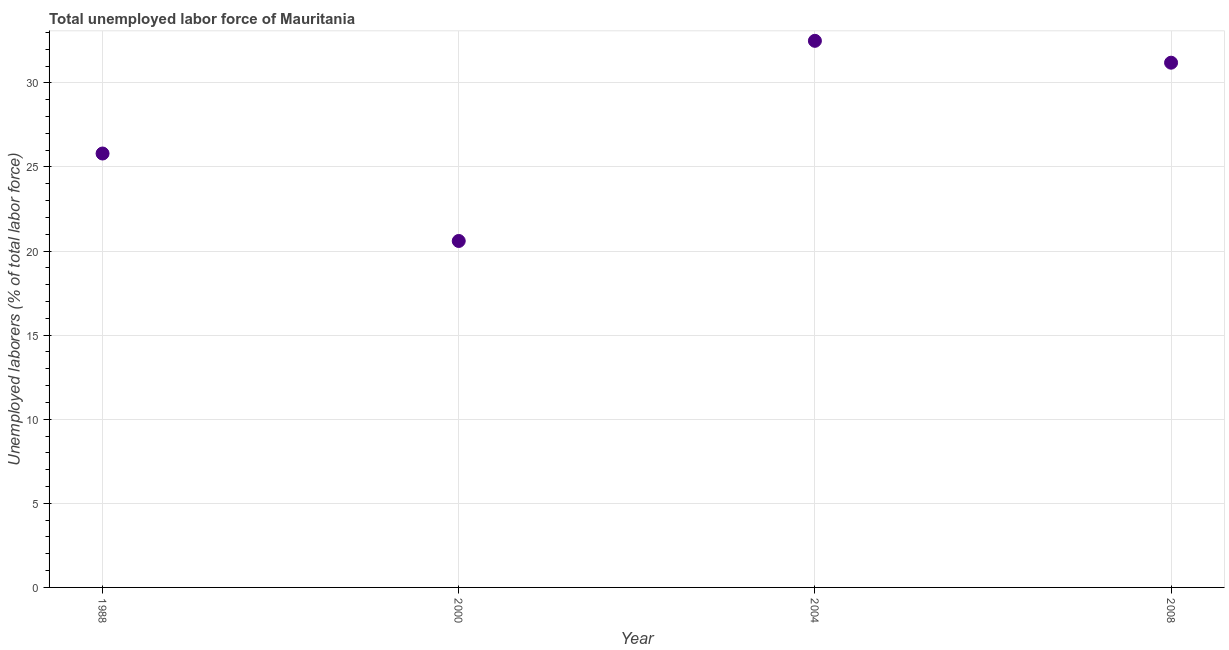What is the total unemployed labour force in 2000?
Make the answer very short. 20.6. Across all years, what is the maximum total unemployed labour force?
Your answer should be very brief. 32.5. Across all years, what is the minimum total unemployed labour force?
Your response must be concise. 20.6. In which year was the total unemployed labour force maximum?
Offer a very short reply. 2004. In which year was the total unemployed labour force minimum?
Offer a very short reply. 2000. What is the sum of the total unemployed labour force?
Your response must be concise. 110.1. What is the difference between the total unemployed labour force in 2000 and 2004?
Your answer should be compact. -11.9. What is the average total unemployed labour force per year?
Offer a very short reply. 27.53. What is the median total unemployed labour force?
Provide a short and direct response. 28.5. Do a majority of the years between 2004 and 2000 (inclusive) have total unemployed labour force greater than 13 %?
Keep it short and to the point. No. What is the ratio of the total unemployed labour force in 1988 to that in 2004?
Provide a short and direct response. 0.79. Is the total unemployed labour force in 2000 less than that in 2004?
Offer a terse response. Yes. Is the difference between the total unemployed labour force in 2004 and 2008 greater than the difference between any two years?
Provide a short and direct response. No. What is the difference between the highest and the second highest total unemployed labour force?
Make the answer very short. 1.3. What is the difference between the highest and the lowest total unemployed labour force?
Offer a very short reply. 11.9. Does the total unemployed labour force monotonically increase over the years?
Keep it short and to the point. No. How many years are there in the graph?
Keep it short and to the point. 4. Are the values on the major ticks of Y-axis written in scientific E-notation?
Give a very brief answer. No. What is the title of the graph?
Offer a terse response. Total unemployed labor force of Mauritania. What is the label or title of the X-axis?
Provide a short and direct response. Year. What is the label or title of the Y-axis?
Make the answer very short. Unemployed laborers (% of total labor force). What is the Unemployed laborers (% of total labor force) in 1988?
Offer a terse response. 25.8. What is the Unemployed laborers (% of total labor force) in 2000?
Your response must be concise. 20.6. What is the Unemployed laborers (% of total labor force) in 2004?
Offer a terse response. 32.5. What is the Unemployed laborers (% of total labor force) in 2008?
Provide a succinct answer. 31.2. What is the difference between the Unemployed laborers (% of total labor force) in 1988 and 2000?
Provide a short and direct response. 5.2. What is the difference between the Unemployed laborers (% of total labor force) in 1988 and 2004?
Keep it short and to the point. -6.7. What is the difference between the Unemployed laborers (% of total labor force) in 1988 and 2008?
Keep it short and to the point. -5.4. What is the difference between the Unemployed laborers (% of total labor force) in 2004 and 2008?
Your answer should be very brief. 1.3. What is the ratio of the Unemployed laborers (% of total labor force) in 1988 to that in 2000?
Your answer should be very brief. 1.25. What is the ratio of the Unemployed laborers (% of total labor force) in 1988 to that in 2004?
Offer a terse response. 0.79. What is the ratio of the Unemployed laborers (% of total labor force) in 1988 to that in 2008?
Your answer should be very brief. 0.83. What is the ratio of the Unemployed laborers (% of total labor force) in 2000 to that in 2004?
Your answer should be compact. 0.63. What is the ratio of the Unemployed laborers (% of total labor force) in 2000 to that in 2008?
Offer a terse response. 0.66. What is the ratio of the Unemployed laborers (% of total labor force) in 2004 to that in 2008?
Provide a short and direct response. 1.04. 